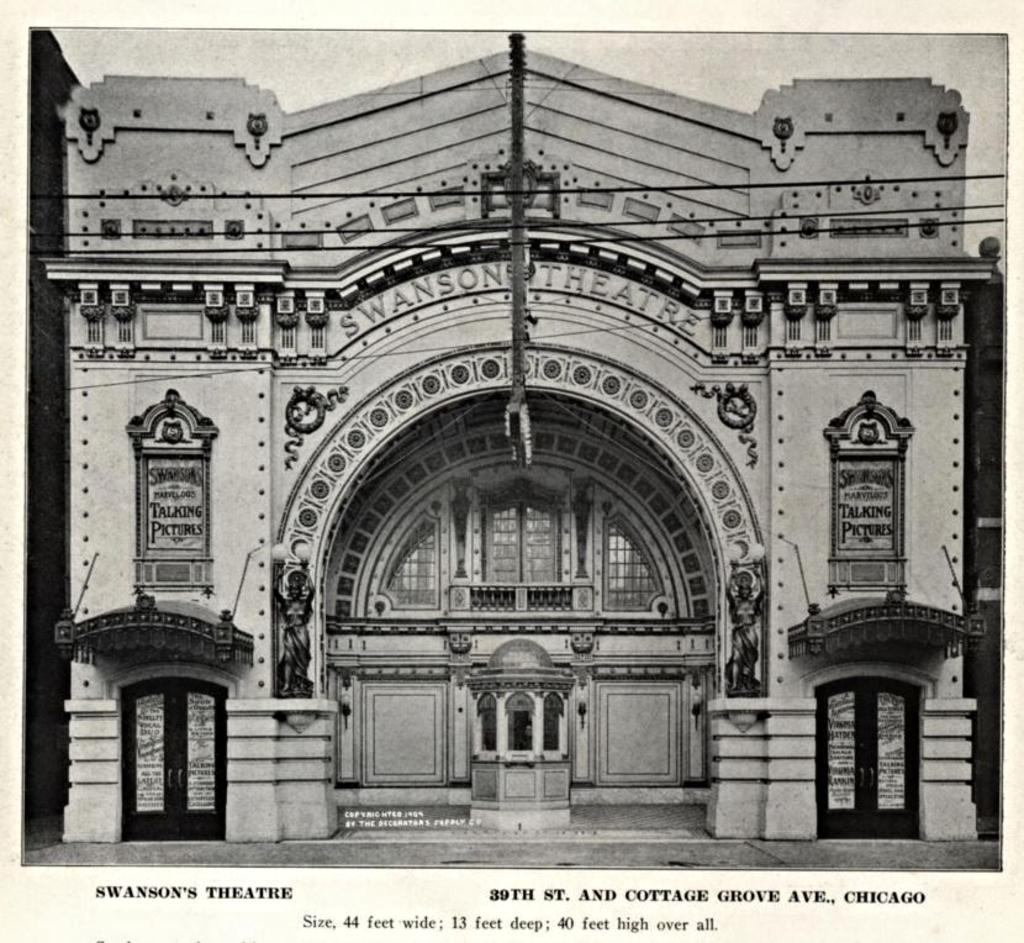What type of image is present in the photograph? The image contains a black and white photograph. What can be seen in the photograph? There is a building, a glass window, a board, and wires visible in the photograph. Is there any text present in the photograph? Yes, there is text at the bottom of the photograph. What type of apple is being taught in the photograph? There is no apple or teaching activity present in the photograph. 